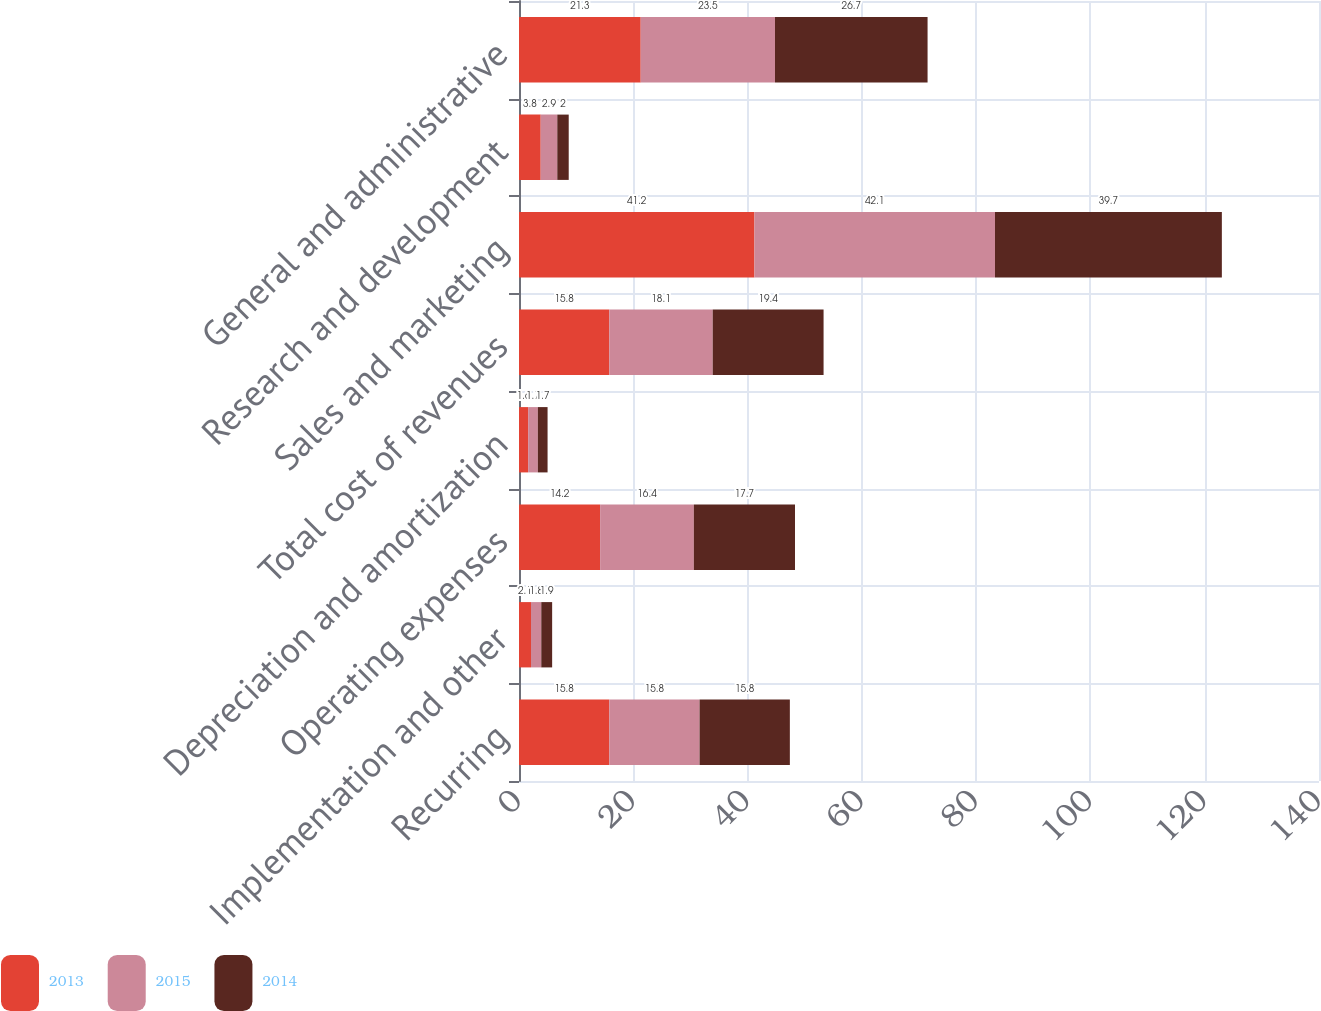Convert chart to OTSL. <chart><loc_0><loc_0><loc_500><loc_500><stacked_bar_chart><ecel><fcel>Recurring<fcel>Implementation and other<fcel>Operating expenses<fcel>Depreciation and amortization<fcel>Total cost of revenues<fcel>Sales and marketing<fcel>Research and development<fcel>General and administrative<nl><fcel>2013<fcel>15.8<fcel>2.1<fcel>14.2<fcel>1.6<fcel>15.8<fcel>41.2<fcel>3.8<fcel>21.3<nl><fcel>2015<fcel>15.8<fcel>1.8<fcel>16.4<fcel>1.7<fcel>18.1<fcel>42.1<fcel>2.9<fcel>23.5<nl><fcel>2014<fcel>15.8<fcel>1.9<fcel>17.7<fcel>1.7<fcel>19.4<fcel>39.7<fcel>2<fcel>26.7<nl></chart> 